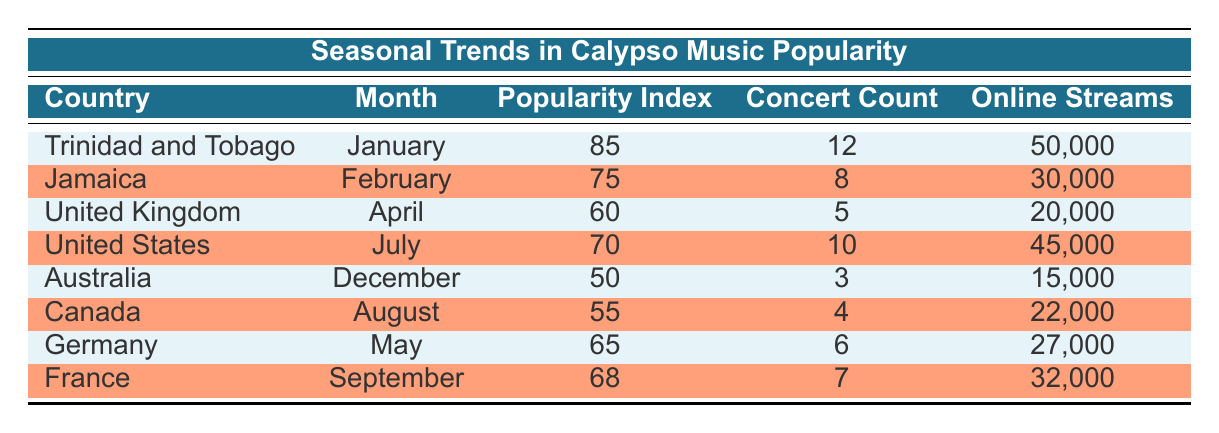What is the highest popularity index for calypso music in the table? The table shows that Trinidad and Tobago has the highest popularity index at 85 in January.
Answer: 85 Which country has the most concert counts for calypso music? Trinidad and Tobago has the highest concert count with 12 concerts in January.
Answer: 12 What is the total number of online streams in the United States and Canada combined? The United States has 45,000 online streams and Canada has 22,000. Adding these gives 45,000 + 22,000 = 67,000 total online streams.
Answer: 67,000 Is the popularity index for calypso music higher in August than in December? The popularity index for Canada in August is 55, while for Australia in December it is 50. Since 55 is greater than 50, the statement is true.
Answer: Yes What is the average popularity index for the countries listed in the table? The popularity indices are 85, 75, 60, 70, 50, 55, 65, and 68. Summing these gives 85 + 75 + 60 + 70 + 50 + 55 + 65 + 68 = 628. There are 8 entries, so the average is 628 / 8 = 78.5.
Answer: 78.5 